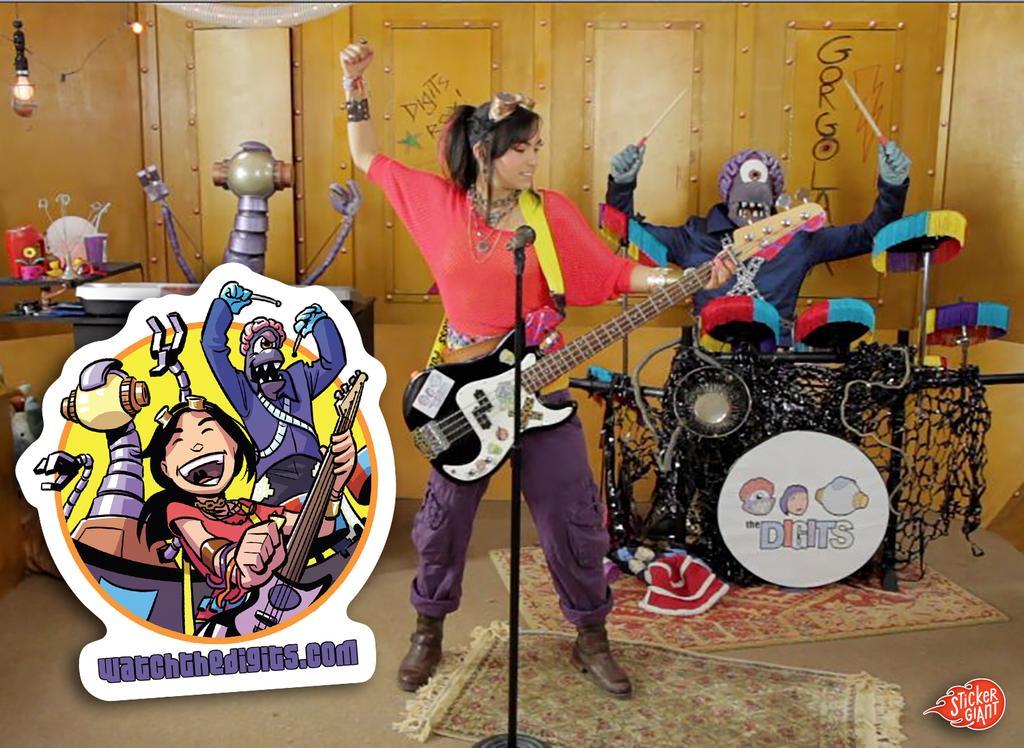Describe this image in one or two sentences. In the center of the image there is a lady standing and holding a guitar in her hand. There is a mic placed before her behind her there is a person who is playing a band. There is a mat on the floor. In the background there is a wall and a light. 